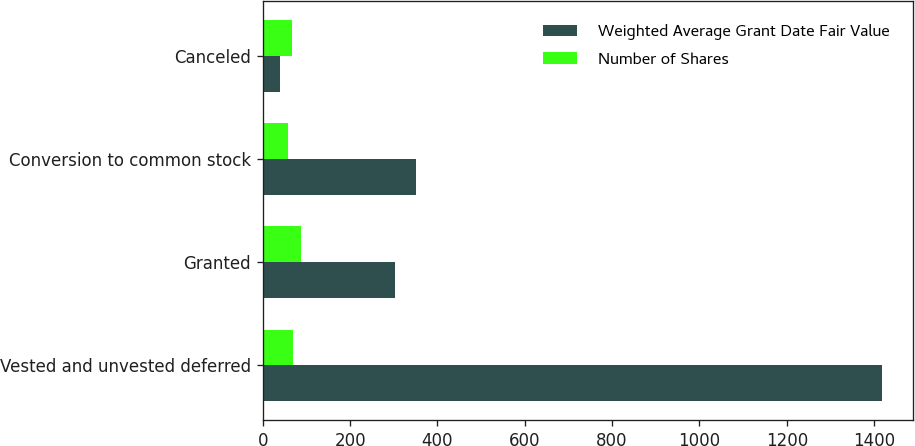<chart> <loc_0><loc_0><loc_500><loc_500><stacked_bar_chart><ecel><fcel>Vested and unvested deferred<fcel>Granted<fcel>Conversion to common stock<fcel>Canceled<nl><fcel>Weighted Average Grant Date Fair Value<fcel>1419<fcel>302<fcel>351<fcel>39<nl><fcel>Number of Shares<fcel>68.5<fcel>88.01<fcel>56.83<fcel>66.25<nl></chart> 